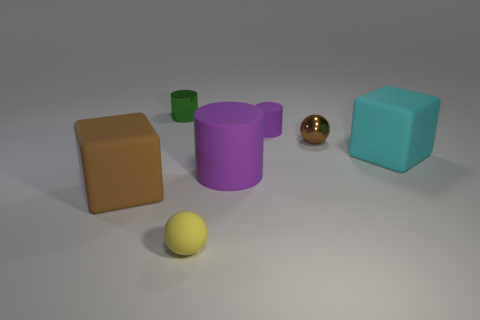What is the material of the purple cylinder that is the same size as the yellow object? The purple cylinder appears to have a matte surface suggesting it could be made of a non-reflective material like rubber or hard plastic. However, without specific texture details or additional information, it's challenging to determine the exact material solely from the image. 